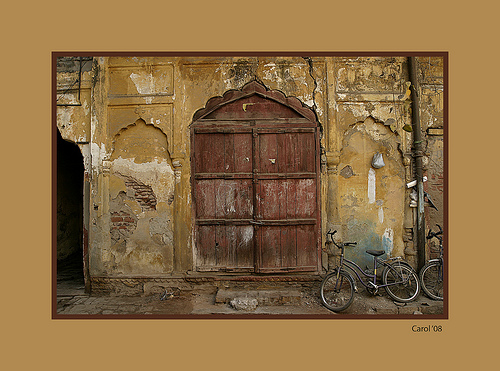Describe the textures visible in the image and how they contribute to the overall ambiance. The visible textures range from the rough, peeling surfaces of the walls to the smooth, worn wood of the door and the metallic sleekness of the bicycle. These elements combine to create a sense of historical depth and decay, evoking a nostalgic and melancholic ambiance. 